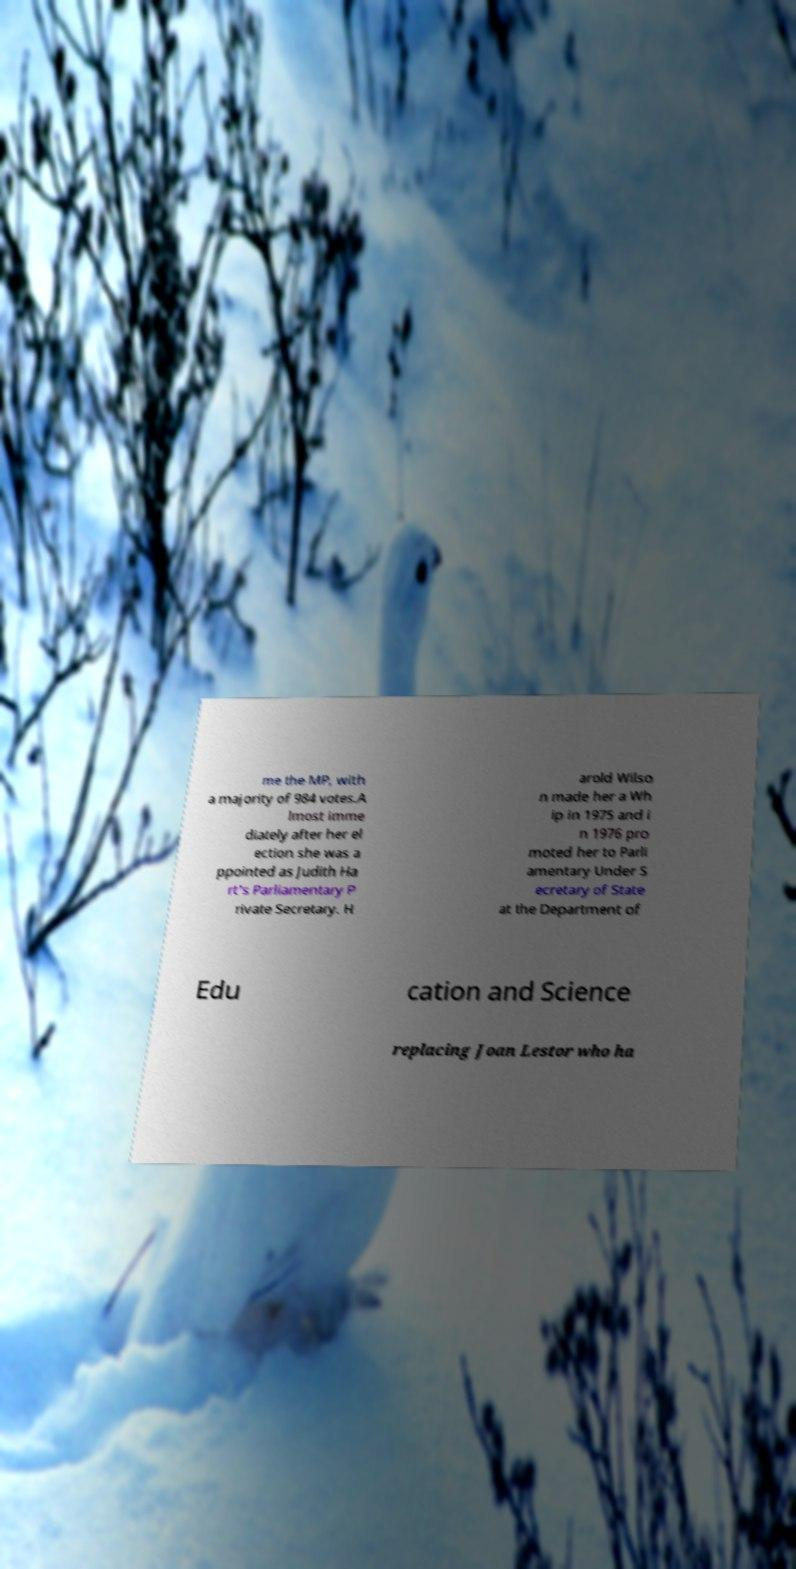I need the written content from this picture converted into text. Can you do that? me the MP, with a majority of 984 votes.A lmost imme diately after her el ection she was a ppointed as Judith Ha rt's Parliamentary P rivate Secretary. H arold Wilso n made her a Wh ip in 1975 and i n 1976 pro moted her to Parli amentary Under S ecretary of State at the Department of Edu cation and Science replacing Joan Lestor who ha 